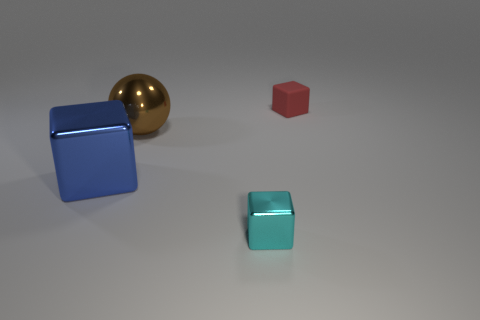Subtract all gray cubes. Subtract all cyan spheres. How many cubes are left? 3 Add 4 tiny cyan metallic cubes. How many objects exist? 8 Subtract all blocks. How many objects are left? 1 Add 2 rubber spheres. How many rubber spheres exist? 2 Subtract 0 blue cylinders. How many objects are left? 4 Subtract all small cyan shiny blocks. Subtract all small red matte things. How many objects are left? 2 Add 4 cyan metal blocks. How many cyan metal blocks are left? 5 